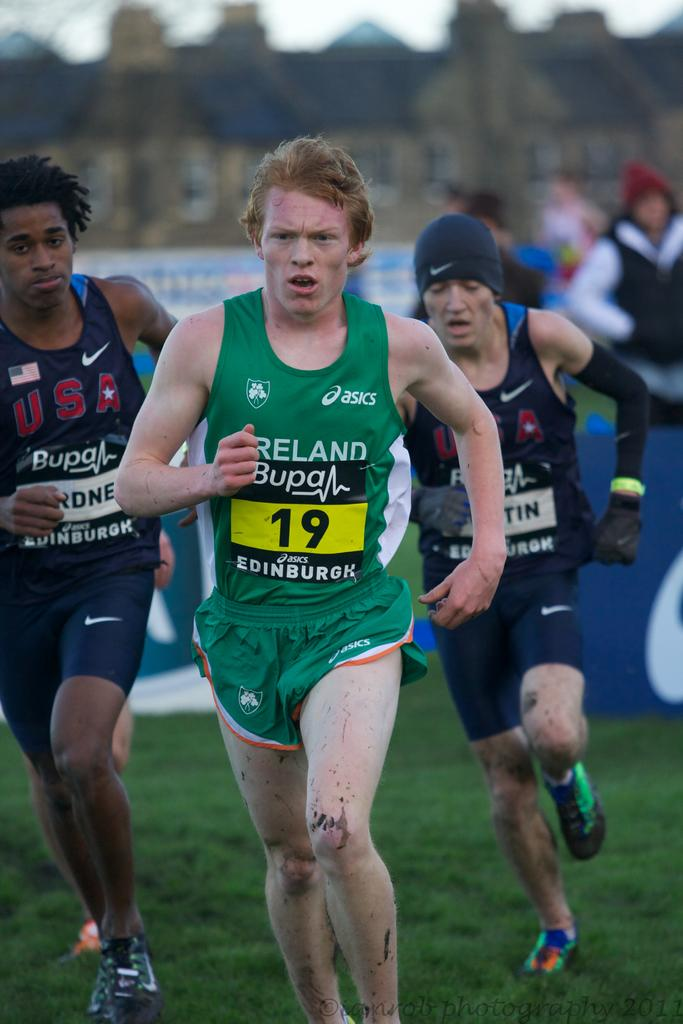Provide a one-sentence caption for the provided image. Men are running in a race and the one in green has number 19. 